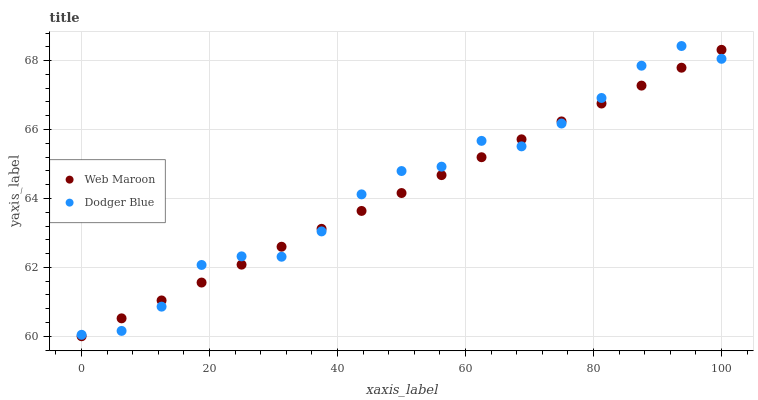Does Web Maroon have the minimum area under the curve?
Answer yes or no. Yes. Does Dodger Blue have the maximum area under the curve?
Answer yes or no. Yes. Does Web Maroon have the maximum area under the curve?
Answer yes or no. No. Is Web Maroon the smoothest?
Answer yes or no. Yes. Is Dodger Blue the roughest?
Answer yes or no. Yes. Is Web Maroon the roughest?
Answer yes or no. No. Does Web Maroon have the lowest value?
Answer yes or no. Yes. Does Dodger Blue have the highest value?
Answer yes or no. Yes. Does Web Maroon have the highest value?
Answer yes or no. No. Does Dodger Blue intersect Web Maroon?
Answer yes or no. Yes. Is Dodger Blue less than Web Maroon?
Answer yes or no. No. Is Dodger Blue greater than Web Maroon?
Answer yes or no. No. 